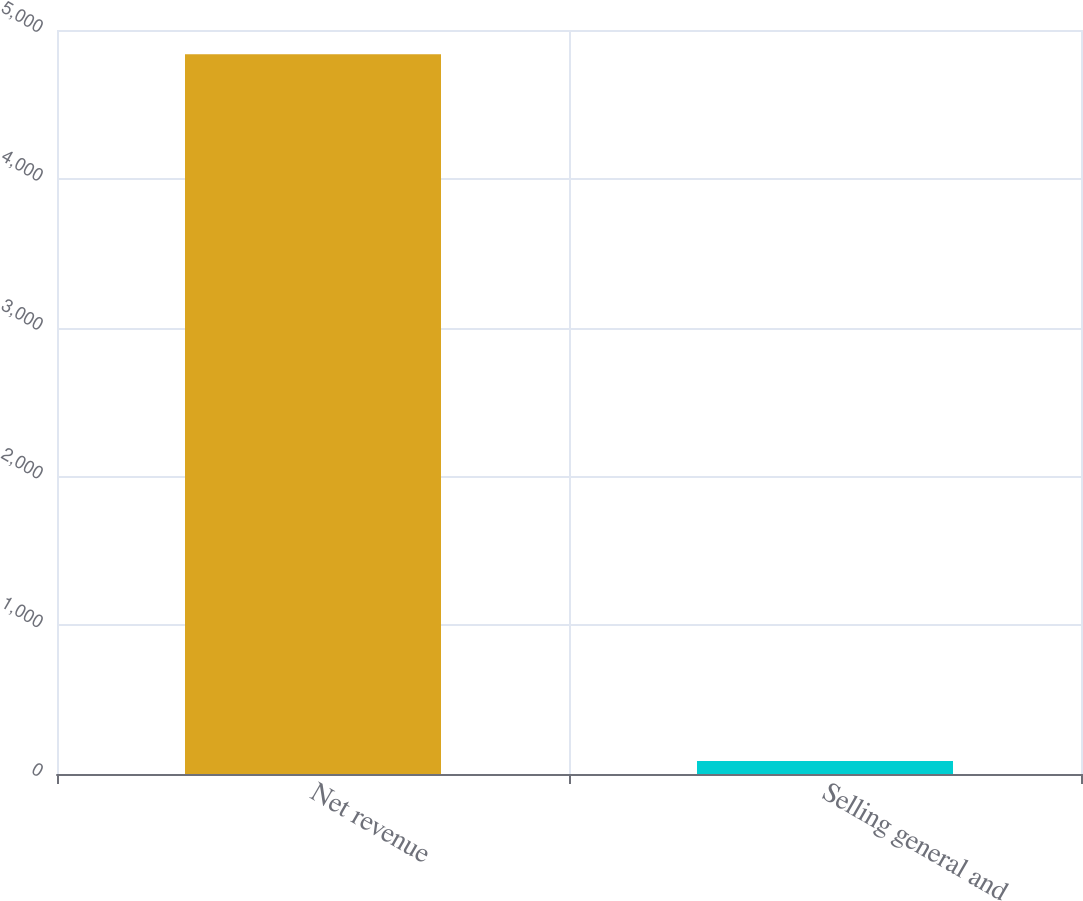<chart> <loc_0><loc_0><loc_500><loc_500><bar_chart><fcel>Net revenue<fcel>Selling general and<nl><fcel>4837<fcel>87<nl></chart> 